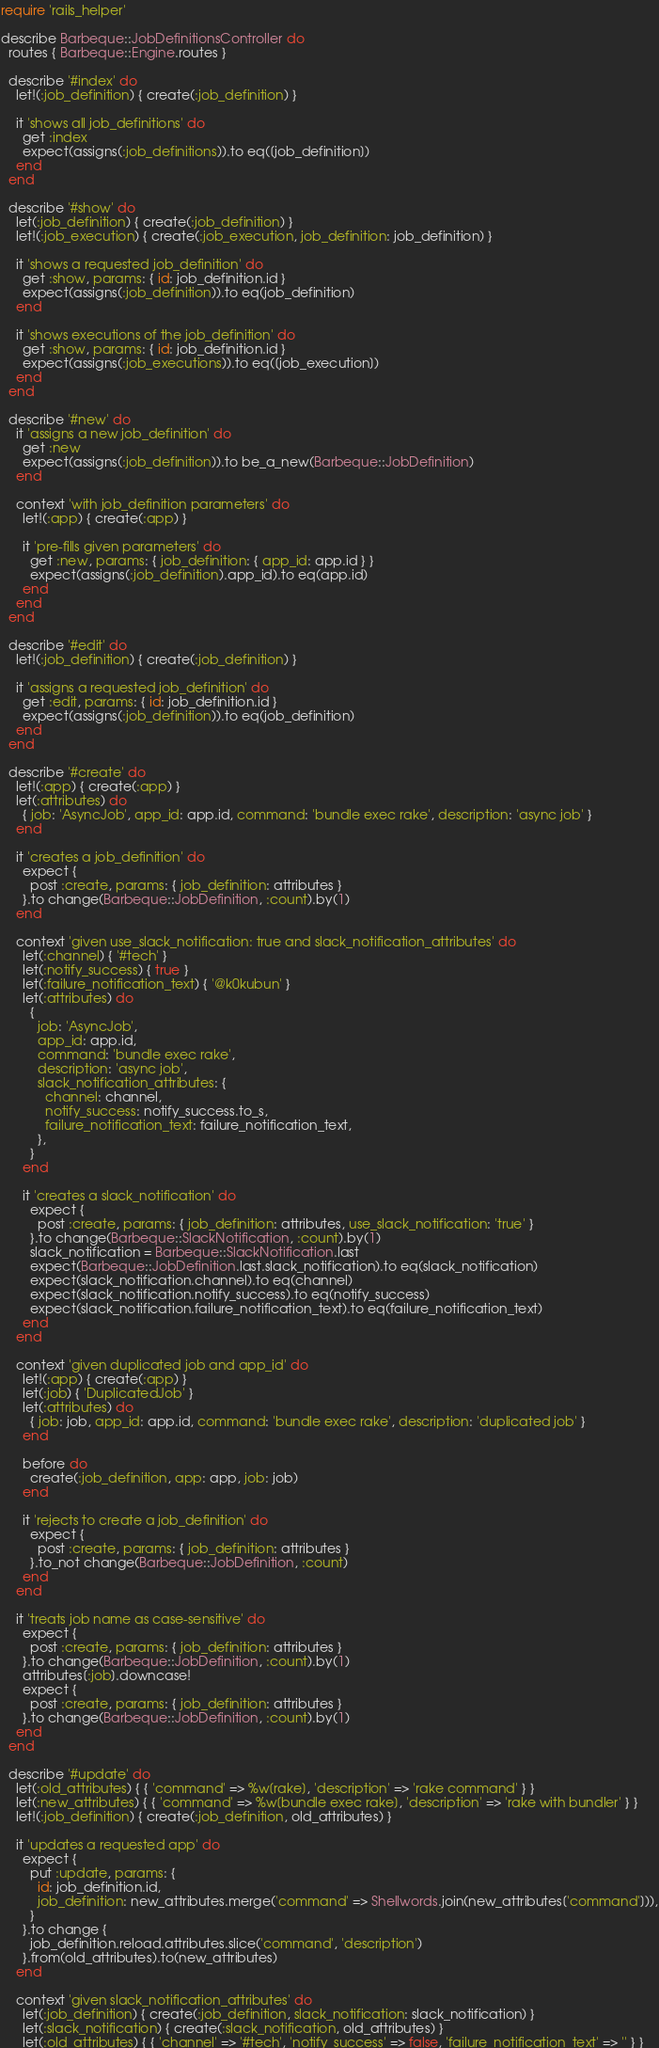Convert code to text. <code><loc_0><loc_0><loc_500><loc_500><_Ruby_>require 'rails_helper'

describe Barbeque::JobDefinitionsController do
  routes { Barbeque::Engine.routes }

  describe '#index' do
    let!(:job_definition) { create(:job_definition) }

    it 'shows all job_definitions' do
      get :index
      expect(assigns(:job_definitions)).to eq([job_definition])
    end
  end

  describe '#show' do
    let(:job_definition) { create(:job_definition) }
    let!(:job_execution) { create(:job_execution, job_definition: job_definition) }

    it 'shows a requested job_definition' do
      get :show, params: { id: job_definition.id }
      expect(assigns(:job_definition)).to eq(job_definition)
    end

    it 'shows executions of the job_definition' do
      get :show, params: { id: job_definition.id }
      expect(assigns(:job_executions)).to eq([job_execution])
    end
  end

  describe '#new' do
    it 'assigns a new job_definition' do
      get :new
      expect(assigns(:job_definition)).to be_a_new(Barbeque::JobDefinition)
    end

    context 'with job_definition parameters' do
      let!(:app) { create(:app) }

      it 'pre-fills given parameters' do
        get :new, params: { job_definition: { app_id: app.id } }
        expect(assigns(:job_definition).app_id).to eq(app.id)
      end
    end
  end

  describe '#edit' do
    let!(:job_definition) { create(:job_definition) }

    it 'assigns a requested job_definition' do
      get :edit, params: { id: job_definition.id }
      expect(assigns(:job_definition)).to eq(job_definition)
    end
  end

  describe '#create' do
    let!(:app) { create(:app) }
    let(:attributes) do
      { job: 'AsyncJob', app_id: app.id, command: 'bundle exec rake', description: 'async job' }
    end

    it 'creates a job_definition' do
      expect {
        post :create, params: { job_definition: attributes }
      }.to change(Barbeque::JobDefinition, :count).by(1)
    end

    context 'given use_slack_notification: true and slack_notification_attributes' do
      let(:channel) { '#tech' }
      let(:notify_success) { true }
      let(:failure_notification_text) { '@k0kubun' }
      let(:attributes) do
        {
          job: 'AsyncJob',
          app_id: app.id,
          command: 'bundle exec rake',
          description: 'async job',
          slack_notification_attributes: {
            channel: channel,
            notify_success: notify_success.to_s,
            failure_notification_text: failure_notification_text,
          },
        }
      end

      it 'creates a slack_notification' do
        expect {
          post :create, params: { job_definition: attributes, use_slack_notification: 'true' }
        }.to change(Barbeque::SlackNotification, :count).by(1)
        slack_notification = Barbeque::SlackNotification.last
        expect(Barbeque::JobDefinition.last.slack_notification).to eq(slack_notification)
        expect(slack_notification.channel).to eq(channel)
        expect(slack_notification.notify_success).to eq(notify_success)
        expect(slack_notification.failure_notification_text).to eq(failure_notification_text)
      end
    end

    context 'given duplicated job and app_id' do
      let!(:app) { create(:app) }
      let(:job) { 'DuplicatedJob' }
      let(:attributes) do
        { job: job, app_id: app.id, command: 'bundle exec rake', description: 'duplicated job' }
      end

      before do
        create(:job_definition, app: app, job: job)
      end

      it 'rejects to create a job_definition' do
        expect {
          post :create, params: { job_definition: attributes }
        }.to_not change(Barbeque::JobDefinition, :count)
      end
    end

    it 'treats job name as case-sensitive' do
      expect {
        post :create, params: { job_definition: attributes }
      }.to change(Barbeque::JobDefinition, :count).by(1)
      attributes[:job].downcase!
      expect {
        post :create, params: { job_definition: attributes }
      }.to change(Barbeque::JobDefinition, :count).by(1)
    end
  end

  describe '#update' do
    let(:old_attributes) { { 'command' => %w[rake], 'description' => 'rake command' } }
    let(:new_attributes) { { 'command' => %w[bundle exec rake], 'description' => 'rake with bundler' } }
    let!(:job_definition) { create(:job_definition, old_attributes) }

    it 'updates a requested app' do
      expect {
        put :update, params: {
          id: job_definition.id,
          job_definition: new_attributes.merge('command' => Shellwords.join(new_attributes['command'])),
        }
      }.to change {
        job_definition.reload.attributes.slice('command', 'description')
      }.from(old_attributes).to(new_attributes)
    end

    context 'given slack_notification_attributes' do
      let(:job_definition) { create(:job_definition, slack_notification: slack_notification) }
      let(:slack_notification) { create(:slack_notification, old_attributes) }
      let(:old_attributes) { { 'channel' => '#tech', 'notify_success' => false, 'failure_notification_text' => '' } }</code> 